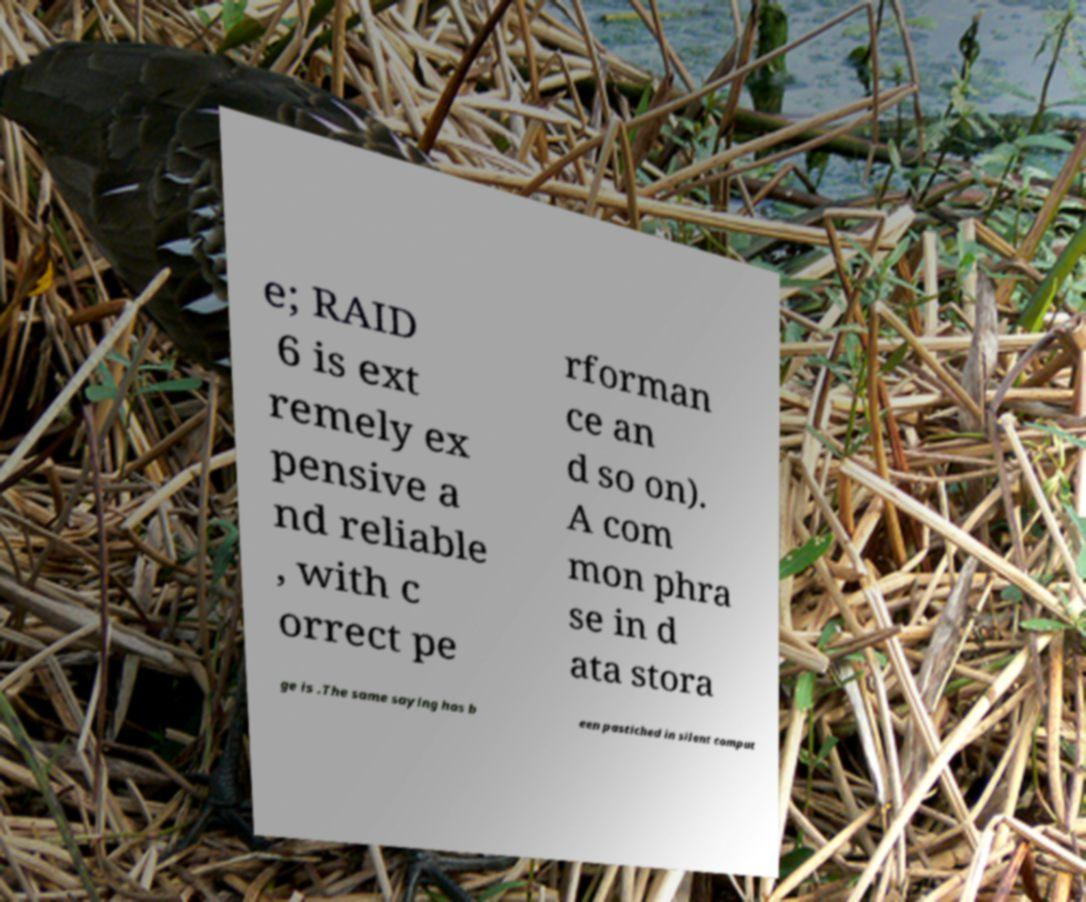Can you read and provide the text displayed in the image?This photo seems to have some interesting text. Can you extract and type it out for me? e; RAID 6 is ext remely ex pensive a nd reliable , with c orrect pe rforman ce an d so on). A com mon phra se in d ata stora ge is .The same saying has b een pastiched in silent comput 